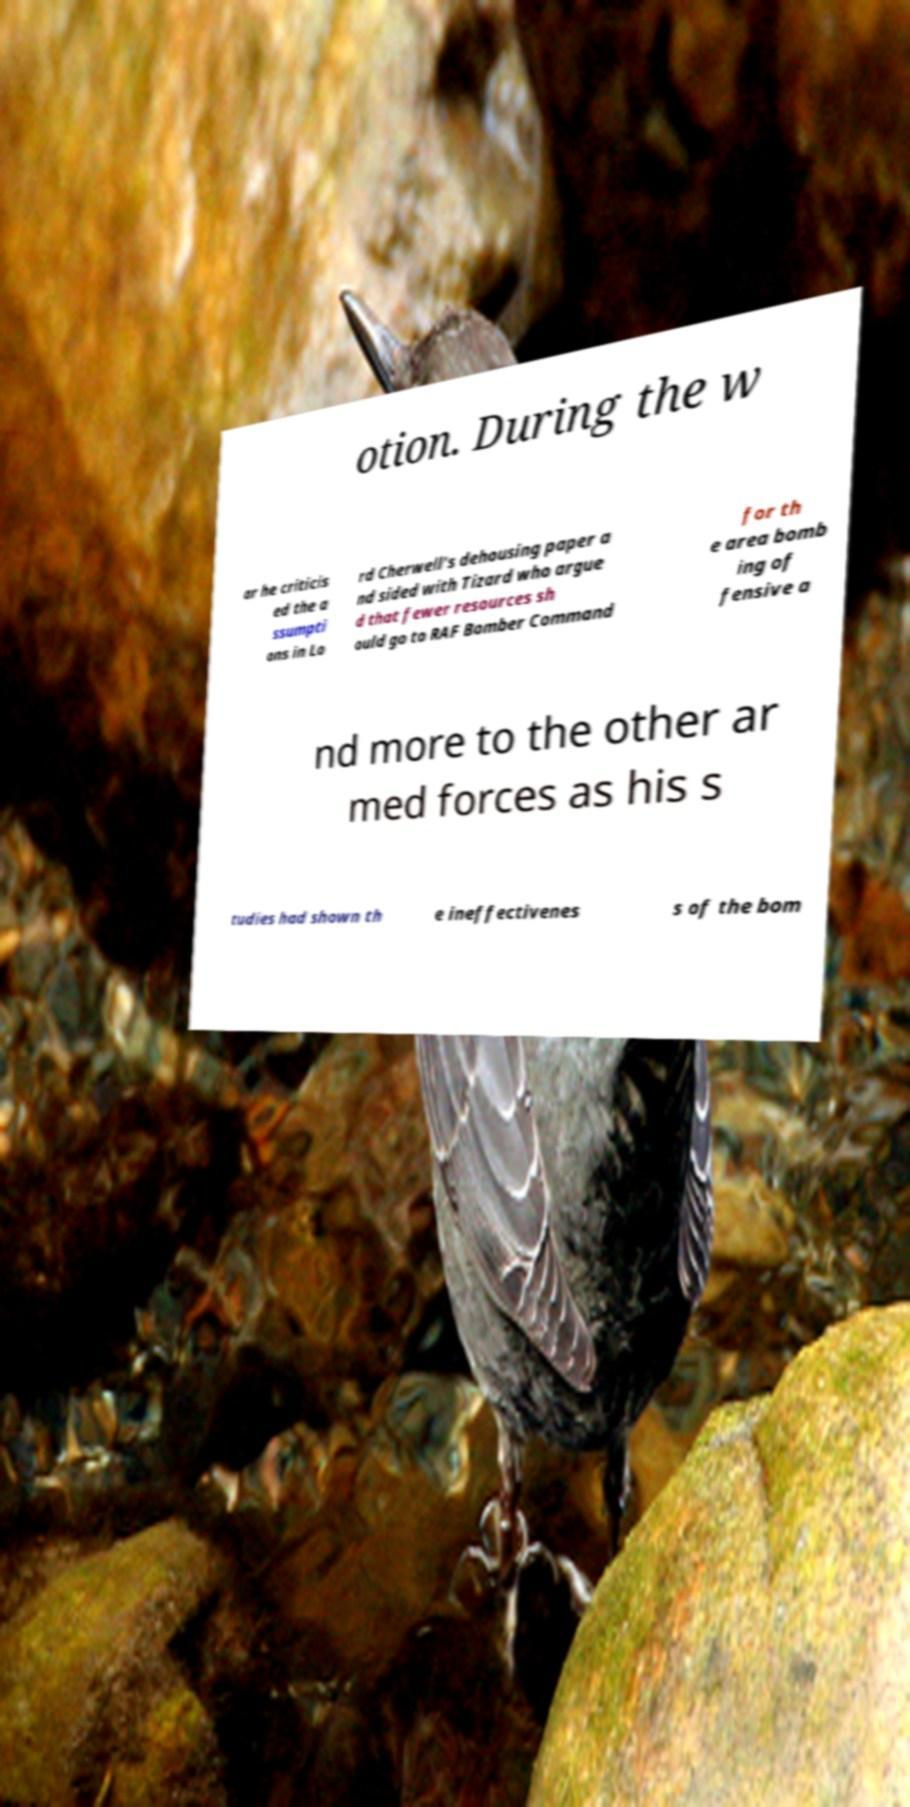What messages or text are displayed in this image? I need them in a readable, typed format. otion. During the w ar he criticis ed the a ssumpti ons in Lo rd Cherwell's dehousing paper a nd sided with Tizard who argue d that fewer resources sh ould go to RAF Bomber Command for th e area bomb ing of fensive a nd more to the other ar med forces as his s tudies had shown th e ineffectivenes s of the bom 